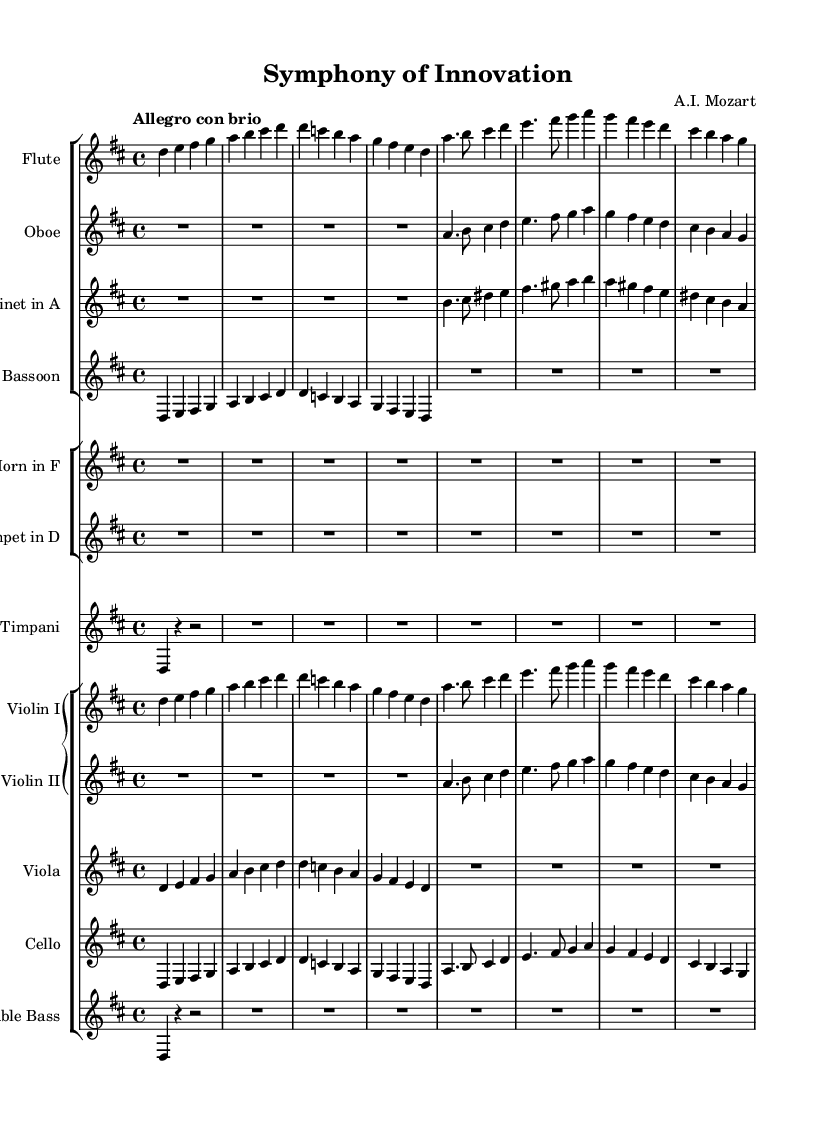What is the key signature of this music? The key signature is D major, as indicated by two sharps (F# and C#) at the beginning of the staff.
Answer: D major What is the time signature of this music? The time signature is 4/4, shown at the beginning of the staff with the fraction indicating four beats in a measure and the quarter note getting the beat.
Answer: 4/4 What tempo marking is indicated for this piece? The tempo marking is "Allegro con brio," which indicates a lively and spirited pace.
Answer: Allegro con brio How many instruments are there in total? The score shows a total of eleven instruments: the flute, oboe, clarinet, bassoon, horn, trumpet, timpani, violin I, violin II, viola, cello, and double bass combined.
Answer: Eleven Which instruments play the same melody in the first section? The flute, violin I, and cello play the same melody in the first section. This can be inferred from their parallel lines in the score where they share identical note patterns.
Answer: Flute, Violin I, Cello What is the overall form of this symphony likely based on typical classical structures? The overall form likely follows the sonata-allegro form typically used in classical symphonies, characterized by an exposition, development, and recapitulation.
Answer: Sonata-allegro form Which instrument does not have a written part in this section? The horn does not have a written part in this section, indicated by the R1 and the long rests in the horn staff.
Answer: Horn 